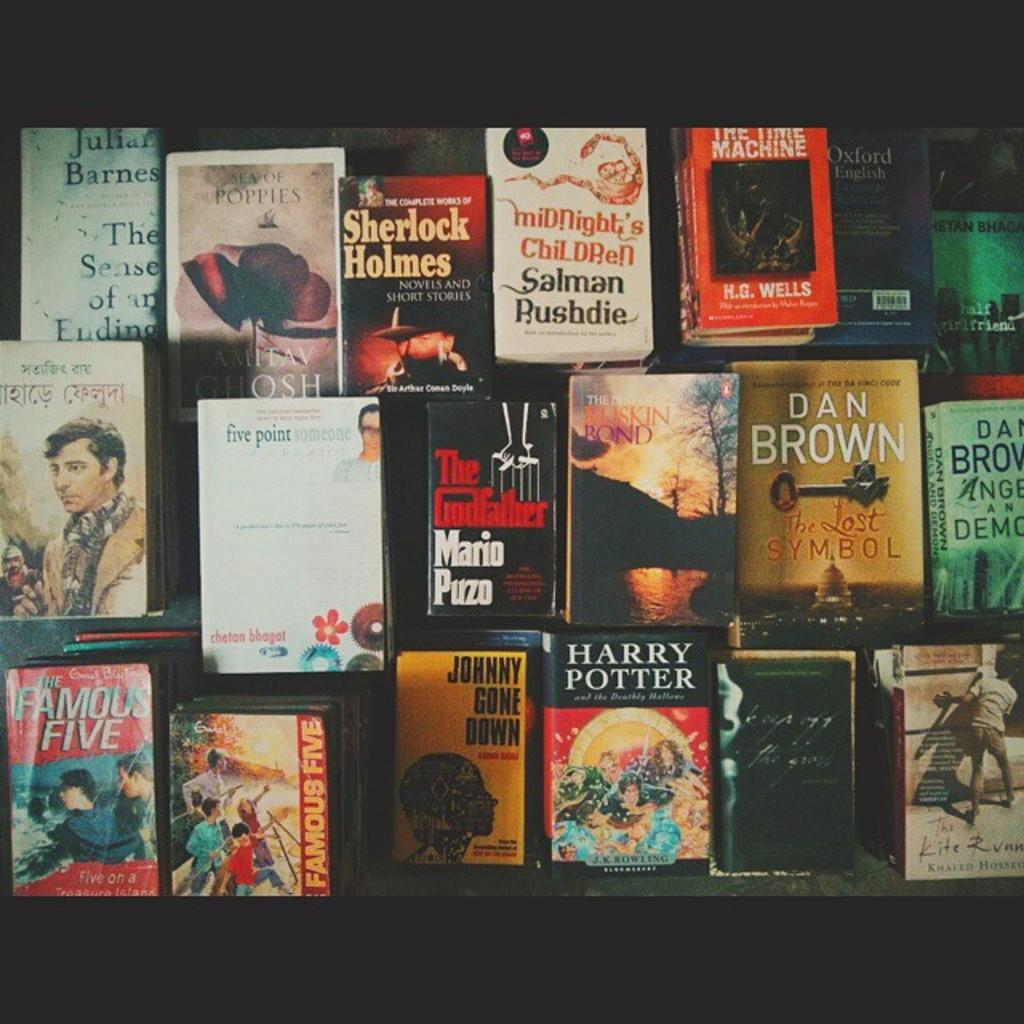<image>
Render a clear and concise summary of the photo. Several books near each other including The Godfather 